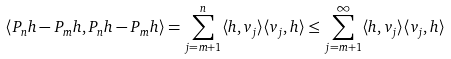<formula> <loc_0><loc_0><loc_500><loc_500>\langle P _ { n } h - P _ { m } h , P _ { n } h - P _ { m } h \rangle = \sum _ { j = m + 1 } ^ { n } \langle h , v _ { j } \rangle \langle v _ { j } , h \rangle \leq \sum _ { j = m + 1 } ^ { \infty } \langle h , v _ { j } \rangle \langle v _ { j } , h \rangle</formula> 